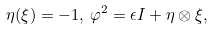<formula> <loc_0><loc_0><loc_500><loc_500>\eta ( \xi ) = - 1 , \, \varphi ^ { 2 } = \epsilon I + \eta \otimes \xi ,</formula> 